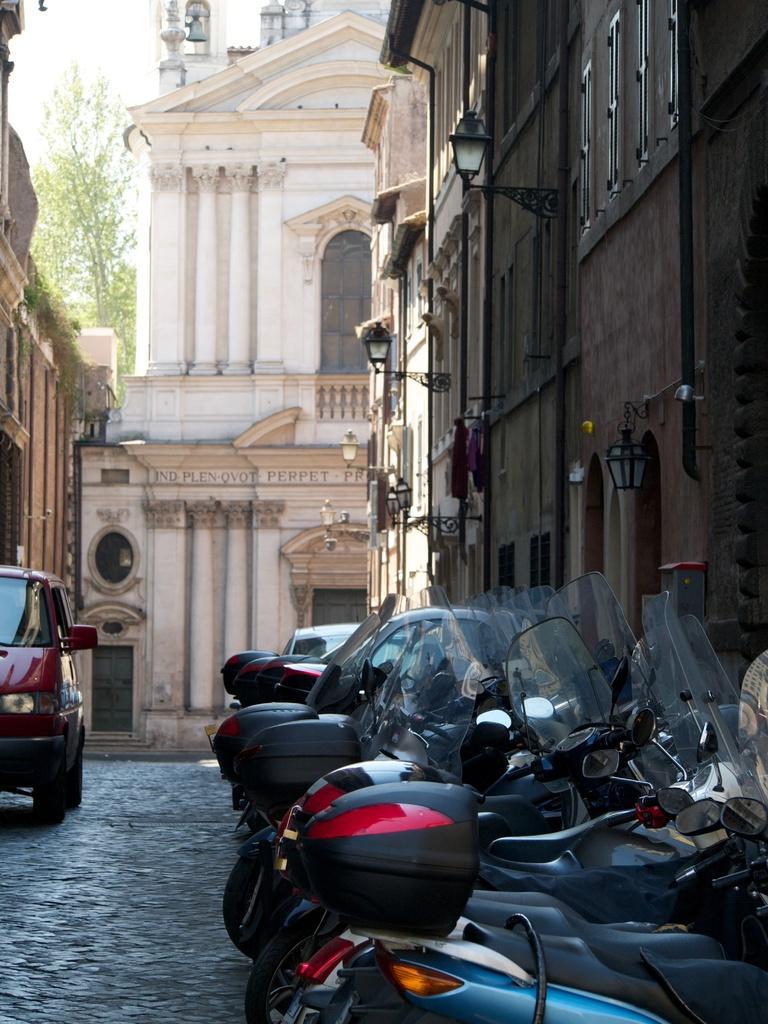In one or two sentences, can you explain what this image depicts? On the right side, we see the bikes parked on the road. Beside that, we see a building and the street lights. On the left side, we see a red car and a building. In the background, we see the trees and a building in white color. 